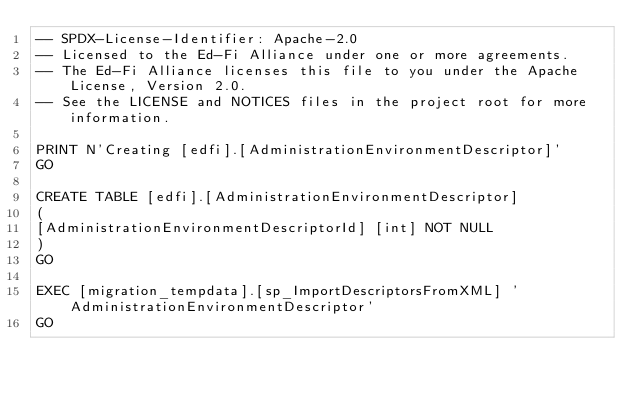<code> <loc_0><loc_0><loc_500><loc_500><_SQL_>-- SPDX-License-Identifier: Apache-2.0
-- Licensed to the Ed-Fi Alliance under one or more agreements.
-- The Ed-Fi Alliance licenses this file to you under the Apache License, Version 2.0.
-- See the LICENSE and NOTICES files in the project root for more information.

PRINT N'Creating [edfi].[AdministrationEnvironmentDescriptor]'
GO

CREATE TABLE [edfi].[AdministrationEnvironmentDescriptor]
(
[AdministrationEnvironmentDescriptorId] [int] NOT NULL
)
GO

EXEC [migration_tempdata].[sp_ImportDescriptorsFromXML] 'AdministrationEnvironmentDescriptor'
GO

</code> 